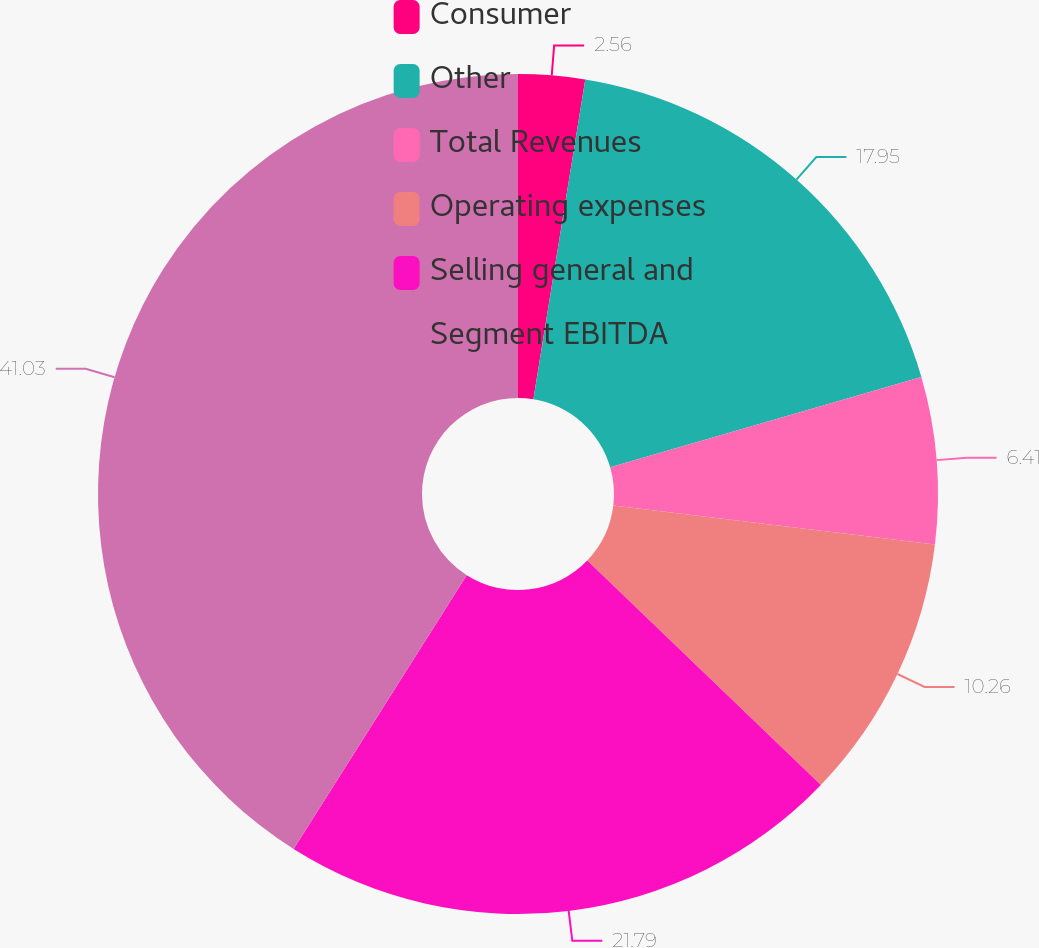<chart> <loc_0><loc_0><loc_500><loc_500><pie_chart><fcel>Consumer<fcel>Other<fcel>Total Revenues<fcel>Operating expenses<fcel>Selling general and<fcel>Segment EBITDA<nl><fcel>2.56%<fcel>17.95%<fcel>6.41%<fcel>10.26%<fcel>21.79%<fcel>41.03%<nl></chart> 